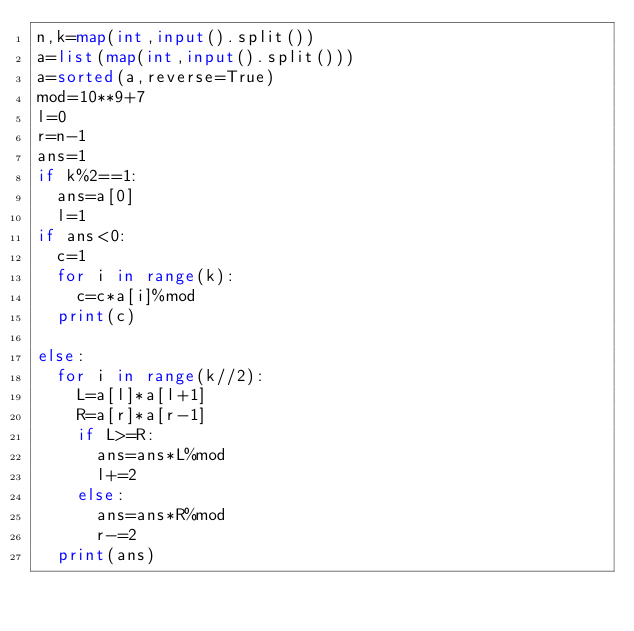<code> <loc_0><loc_0><loc_500><loc_500><_Python_>n,k=map(int,input().split())
a=list(map(int,input().split()))
a=sorted(a,reverse=True)
mod=10**9+7
l=0
r=n-1
ans=1
if k%2==1:
  ans=a[0]
  l=1
if ans<0:
  c=1
  for i in range(k):
    c=c*a[i]%mod
  print(c)
  
else:
  for i in range(k//2):
    L=a[l]*a[l+1]
    R=a[r]*a[r-1]
    if L>=R:
      ans=ans*L%mod
      l+=2
    else:
      ans=ans*R%mod
      r-=2
  print(ans)
      </code> 